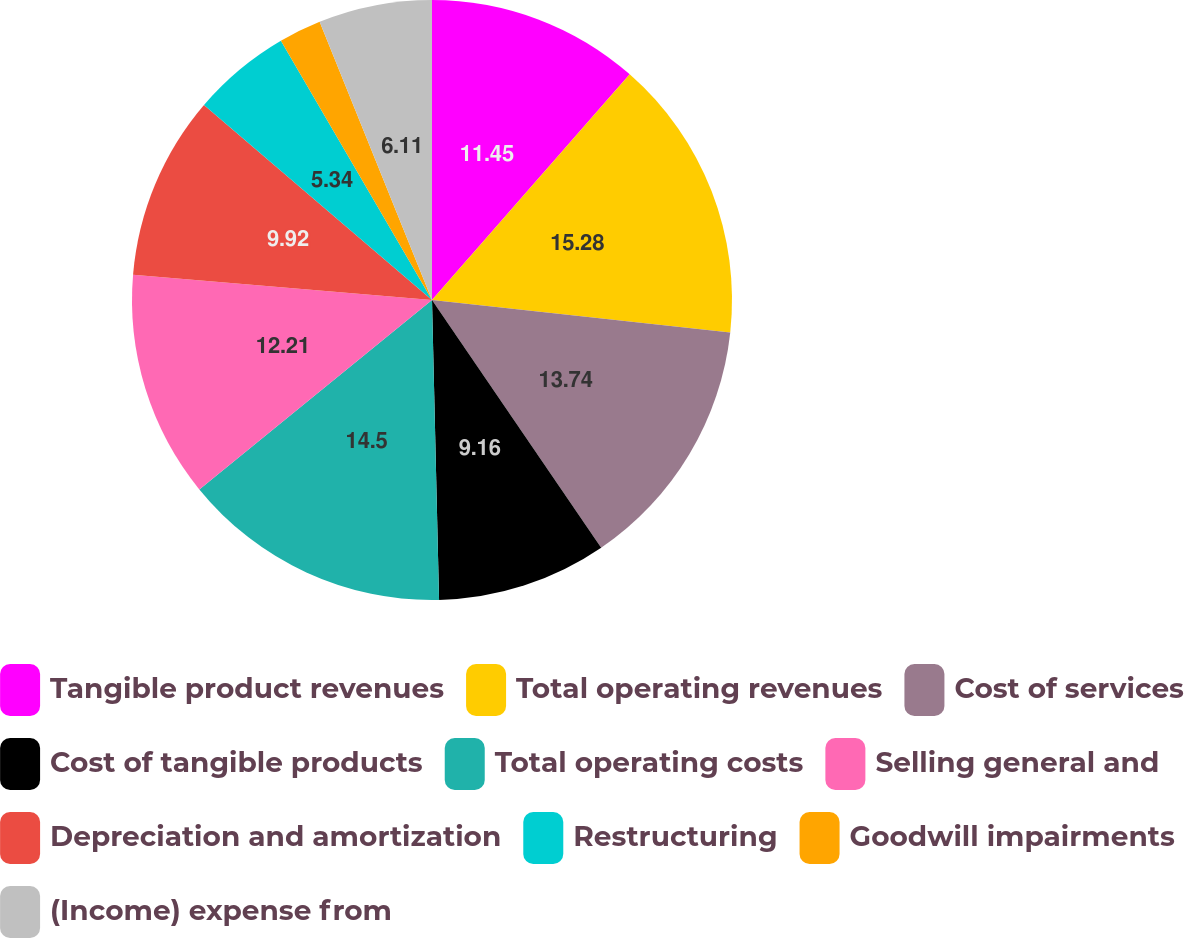<chart> <loc_0><loc_0><loc_500><loc_500><pie_chart><fcel>Tangible product revenues<fcel>Total operating revenues<fcel>Cost of services<fcel>Cost of tangible products<fcel>Total operating costs<fcel>Selling general and<fcel>Depreciation and amortization<fcel>Restructuring<fcel>Goodwill impairments<fcel>(Income) expense from<nl><fcel>11.45%<fcel>15.27%<fcel>13.74%<fcel>9.16%<fcel>14.5%<fcel>12.21%<fcel>9.92%<fcel>5.34%<fcel>2.29%<fcel>6.11%<nl></chart> 